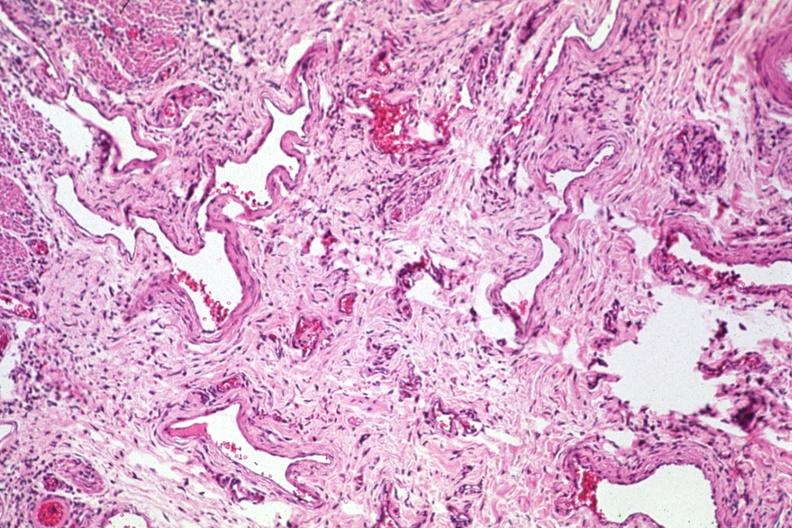what is present?
Answer the question using a single word or phrase. Esophagus 